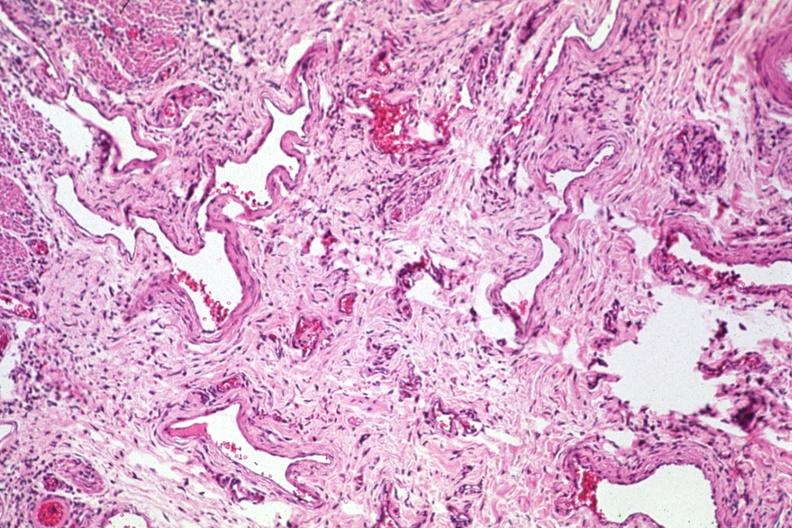what is present?
Answer the question using a single word or phrase. Esophagus 